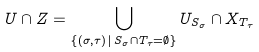Convert formula to latex. <formula><loc_0><loc_0><loc_500><loc_500>U \cap Z = \bigcup _ { \{ ( \sigma , \tau ) \, | \, S _ { \sigma } \cap T _ { \tau } = \emptyset \} } U _ { S _ { \sigma } } \cap X _ { T _ { \tau } }</formula> 